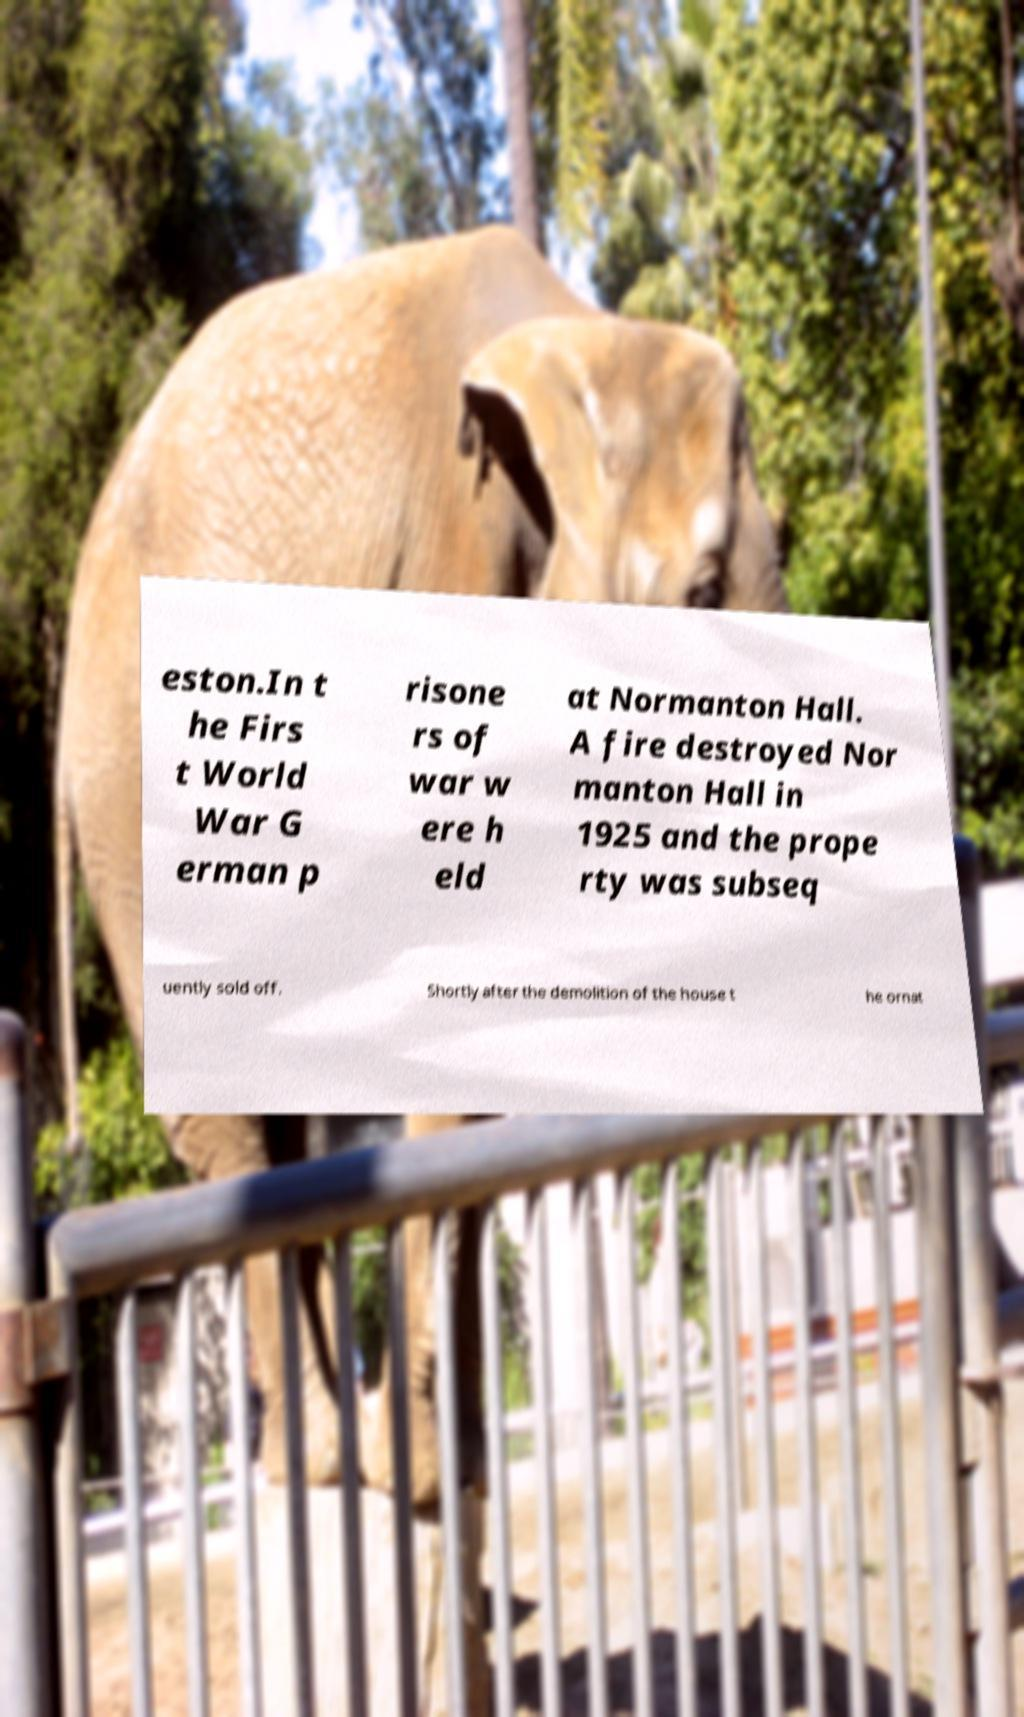There's text embedded in this image that I need extracted. Can you transcribe it verbatim? eston.In t he Firs t World War G erman p risone rs of war w ere h eld at Normanton Hall. A fire destroyed Nor manton Hall in 1925 and the prope rty was subseq uently sold off. Shortly after the demolition of the house t he ornat 